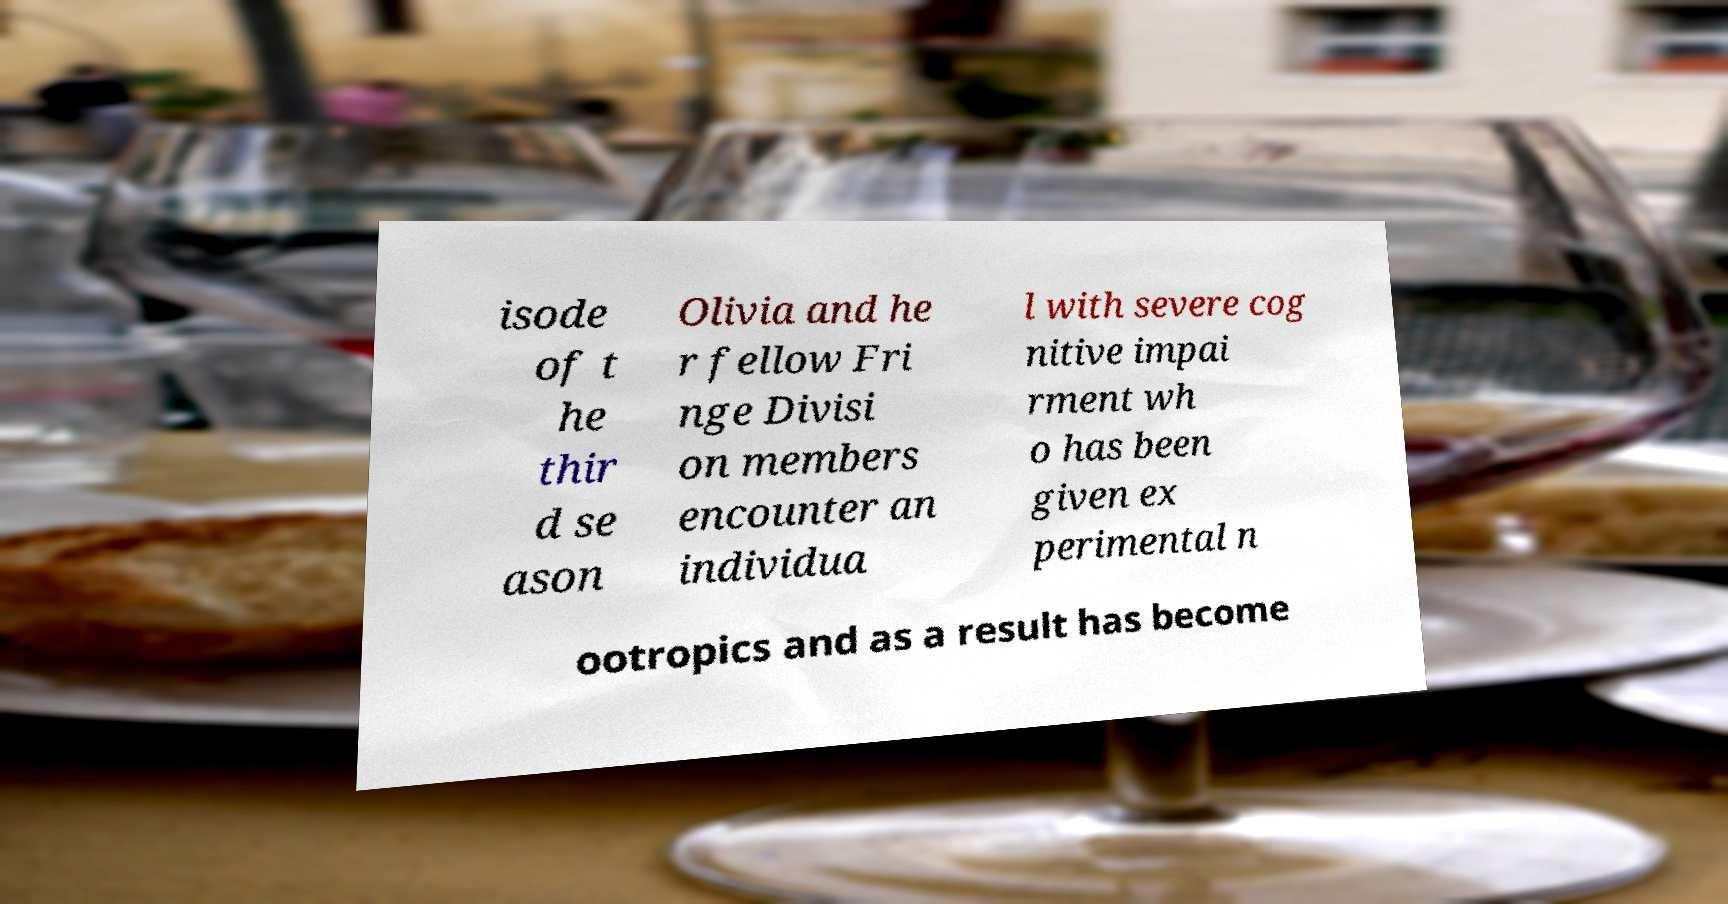For documentation purposes, I need the text within this image transcribed. Could you provide that? isode of t he thir d se ason Olivia and he r fellow Fri nge Divisi on members encounter an individua l with severe cog nitive impai rment wh o has been given ex perimental n ootropics and as a result has become 